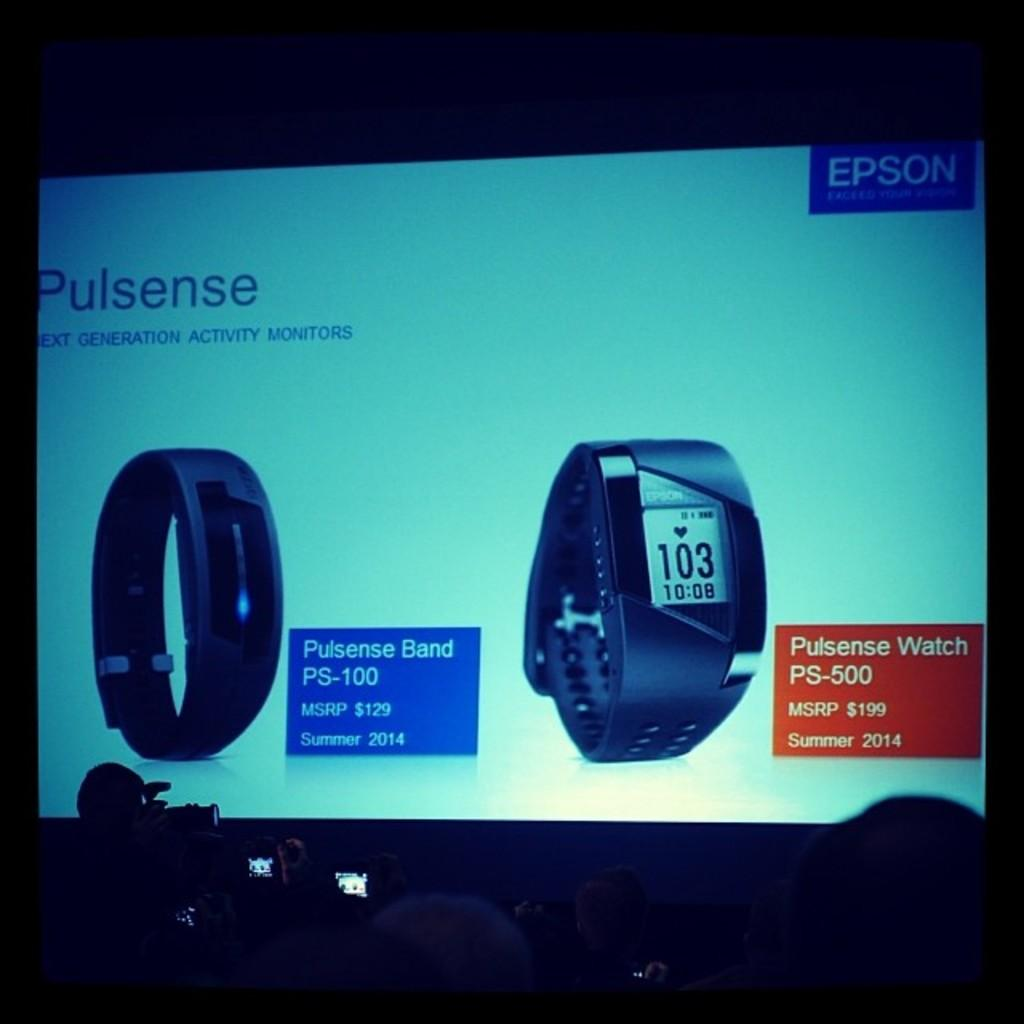<image>
Provide a brief description of the given image. A large screen showing an advertisement for a Pulsense activity monitor. 